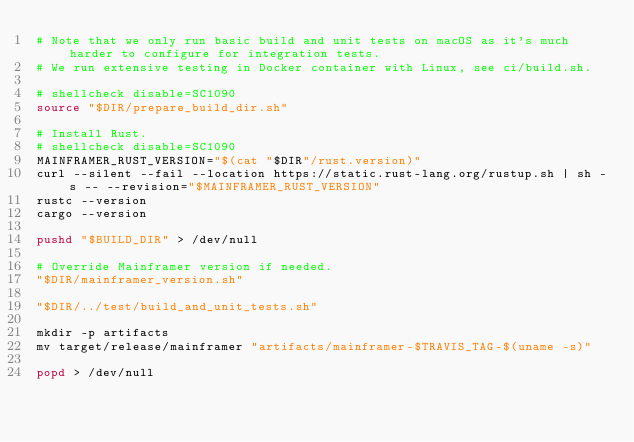Convert code to text. <code><loc_0><loc_0><loc_500><loc_500><_Bash_># Note that we only run basic build and unit tests on macOS as it's much harder to configure for integration tests.
# We run extensive testing in Docker container with Linux, see ci/build.sh.

# shellcheck disable=SC1090
source "$DIR/prepare_build_dir.sh"

# Install Rust.
# shellcheck disable=SC1090
MAINFRAMER_RUST_VERSION="$(cat "$DIR"/rust.version)"
curl --silent --fail --location https://static.rust-lang.org/rustup.sh | sh -s -- --revision="$MAINFRAMER_RUST_VERSION"
rustc --version
cargo --version

pushd "$BUILD_DIR" > /dev/null

# Override Mainframer version if needed.
"$DIR/mainframer_version.sh"

"$DIR/../test/build_and_unit_tests.sh"

mkdir -p artifacts
mv target/release/mainframer "artifacts/mainframer-$TRAVIS_TAG-$(uname -s)"

popd > /dev/null
</code> 